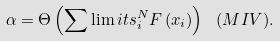Convert formula to latex. <formula><loc_0><loc_0><loc_500><loc_500>\alpha = \Theta \left ( { \sum \lim i t s _ { i } ^ { N } { F \left ( { x _ { i } } \right ) } } \right ) \ ( M I V ) .</formula> 